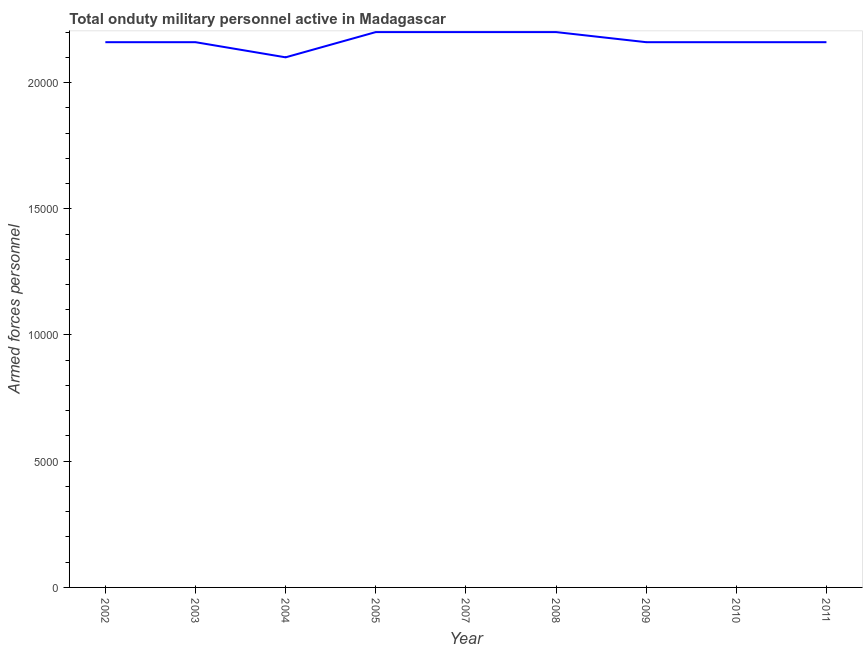What is the number of armed forces personnel in 2004?
Give a very brief answer. 2.10e+04. Across all years, what is the maximum number of armed forces personnel?
Provide a short and direct response. 2.20e+04. Across all years, what is the minimum number of armed forces personnel?
Your answer should be very brief. 2.10e+04. In which year was the number of armed forces personnel minimum?
Make the answer very short. 2004. What is the sum of the number of armed forces personnel?
Make the answer very short. 1.95e+05. What is the difference between the number of armed forces personnel in 2002 and 2009?
Keep it short and to the point. 0. What is the average number of armed forces personnel per year?
Offer a very short reply. 2.17e+04. What is the median number of armed forces personnel?
Keep it short and to the point. 2.16e+04. In how many years, is the number of armed forces personnel greater than 7000 ?
Give a very brief answer. 9. What is the ratio of the number of armed forces personnel in 2004 to that in 2010?
Keep it short and to the point. 0.97. What is the difference between the highest and the lowest number of armed forces personnel?
Provide a short and direct response. 1000. In how many years, is the number of armed forces personnel greater than the average number of armed forces personnel taken over all years?
Offer a terse response. 3. How many years are there in the graph?
Keep it short and to the point. 9. Does the graph contain grids?
Your response must be concise. No. What is the title of the graph?
Keep it short and to the point. Total onduty military personnel active in Madagascar. What is the label or title of the X-axis?
Your response must be concise. Year. What is the label or title of the Y-axis?
Provide a succinct answer. Armed forces personnel. What is the Armed forces personnel in 2002?
Provide a short and direct response. 2.16e+04. What is the Armed forces personnel in 2003?
Offer a very short reply. 2.16e+04. What is the Armed forces personnel of 2004?
Provide a succinct answer. 2.10e+04. What is the Armed forces personnel in 2005?
Your response must be concise. 2.20e+04. What is the Armed forces personnel in 2007?
Your response must be concise. 2.20e+04. What is the Armed forces personnel in 2008?
Give a very brief answer. 2.20e+04. What is the Armed forces personnel in 2009?
Your answer should be compact. 2.16e+04. What is the Armed forces personnel in 2010?
Offer a very short reply. 2.16e+04. What is the Armed forces personnel of 2011?
Your response must be concise. 2.16e+04. What is the difference between the Armed forces personnel in 2002 and 2003?
Offer a very short reply. 0. What is the difference between the Armed forces personnel in 2002 and 2004?
Keep it short and to the point. 600. What is the difference between the Armed forces personnel in 2002 and 2005?
Make the answer very short. -400. What is the difference between the Armed forces personnel in 2002 and 2007?
Ensure brevity in your answer.  -400. What is the difference between the Armed forces personnel in 2002 and 2008?
Your response must be concise. -400. What is the difference between the Armed forces personnel in 2003 and 2004?
Give a very brief answer. 600. What is the difference between the Armed forces personnel in 2003 and 2005?
Your response must be concise. -400. What is the difference between the Armed forces personnel in 2003 and 2007?
Provide a succinct answer. -400. What is the difference between the Armed forces personnel in 2003 and 2008?
Your answer should be compact. -400. What is the difference between the Armed forces personnel in 2003 and 2009?
Make the answer very short. 0. What is the difference between the Armed forces personnel in 2003 and 2010?
Your answer should be very brief. 0. What is the difference between the Armed forces personnel in 2004 and 2005?
Make the answer very short. -1000. What is the difference between the Armed forces personnel in 2004 and 2007?
Your answer should be compact. -1000. What is the difference between the Armed forces personnel in 2004 and 2008?
Make the answer very short. -1000. What is the difference between the Armed forces personnel in 2004 and 2009?
Your response must be concise. -600. What is the difference between the Armed forces personnel in 2004 and 2010?
Provide a short and direct response. -600. What is the difference between the Armed forces personnel in 2004 and 2011?
Provide a short and direct response. -600. What is the difference between the Armed forces personnel in 2005 and 2007?
Ensure brevity in your answer.  0. What is the difference between the Armed forces personnel in 2005 and 2008?
Your answer should be very brief. 0. What is the difference between the Armed forces personnel in 2005 and 2009?
Your answer should be very brief. 400. What is the difference between the Armed forces personnel in 2005 and 2010?
Make the answer very short. 400. What is the difference between the Armed forces personnel in 2005 and 2011?
Provide a succinct answer. 400. What is the difference between the Armed forces personnel in 2007 and 2011?
Make the answer very short. 400. What is the difference between the Armed forces personnel in 2008 and 2011?
Provide a succinct answer. 400. What is the ratio of the Armed forces personnel in 2002 to that in 2007?
Your response must be concise. 0.98. What is the ratio of the Armed forces personnel in 2002 to that in 2009?
Provide a succinct answer. 1. What is the ratio of the Armed forces personnel in 2002 to that in 2010?
Offer a very short reply. 1. What is the ratio of the Armed forces personnel in 2003 to that in 2007?
Give a very brief answer. 0.98. What is the ratio of the Armed forces personnel in 2003 to that in 2010?
Make the answer very short. 1. What is the ratio of the Armed forces personnel in 2004 to that in 2005?
Your answer should be very brief. 0.95. What is the ratio of the Armed forces personnel in 2004 to that in 2007?
Give a very brief answer. 0.95. What is the ratio of the Armed forces personnel in 2004 to that in 2008?
Offer a very short reply. 0.95. What is the ratio of the Armed forces personnel in 2004 to that in 2009?
Give a very brief answer. 0.97. What is the ratio of the Armed forces personnel in 2004 to that in 2010?
Offer a very short reply. 0.97. What is the ratio of the Armed forces personnel in 2004 to that in 2011?
Your response must be concise. 0.97. What is the ratio of the Armed forces personnel in 2005 to that in 2009?
Your answer should be very brief. 1.02. What is the ratio of the Armed forces personnel in 2007 to that in 2009?
Your answer should be compact. 1.02. What is the ratio of the Armed forces personnel in 2007 to that in 2010?
Offer a terse response. 1.02. What is the ratio of the Armed forces personnel in 2008 to that in 2010?
Your response must be concise. 1.02. What is the ratio of the Armed forces personnel in 2008 to that in 2011?
Ensure brevity in your answer.  1.02. What is the ratio of the Armed forces personnel in 2009 to that in 2011?
Provide a short and direct response. 1. 